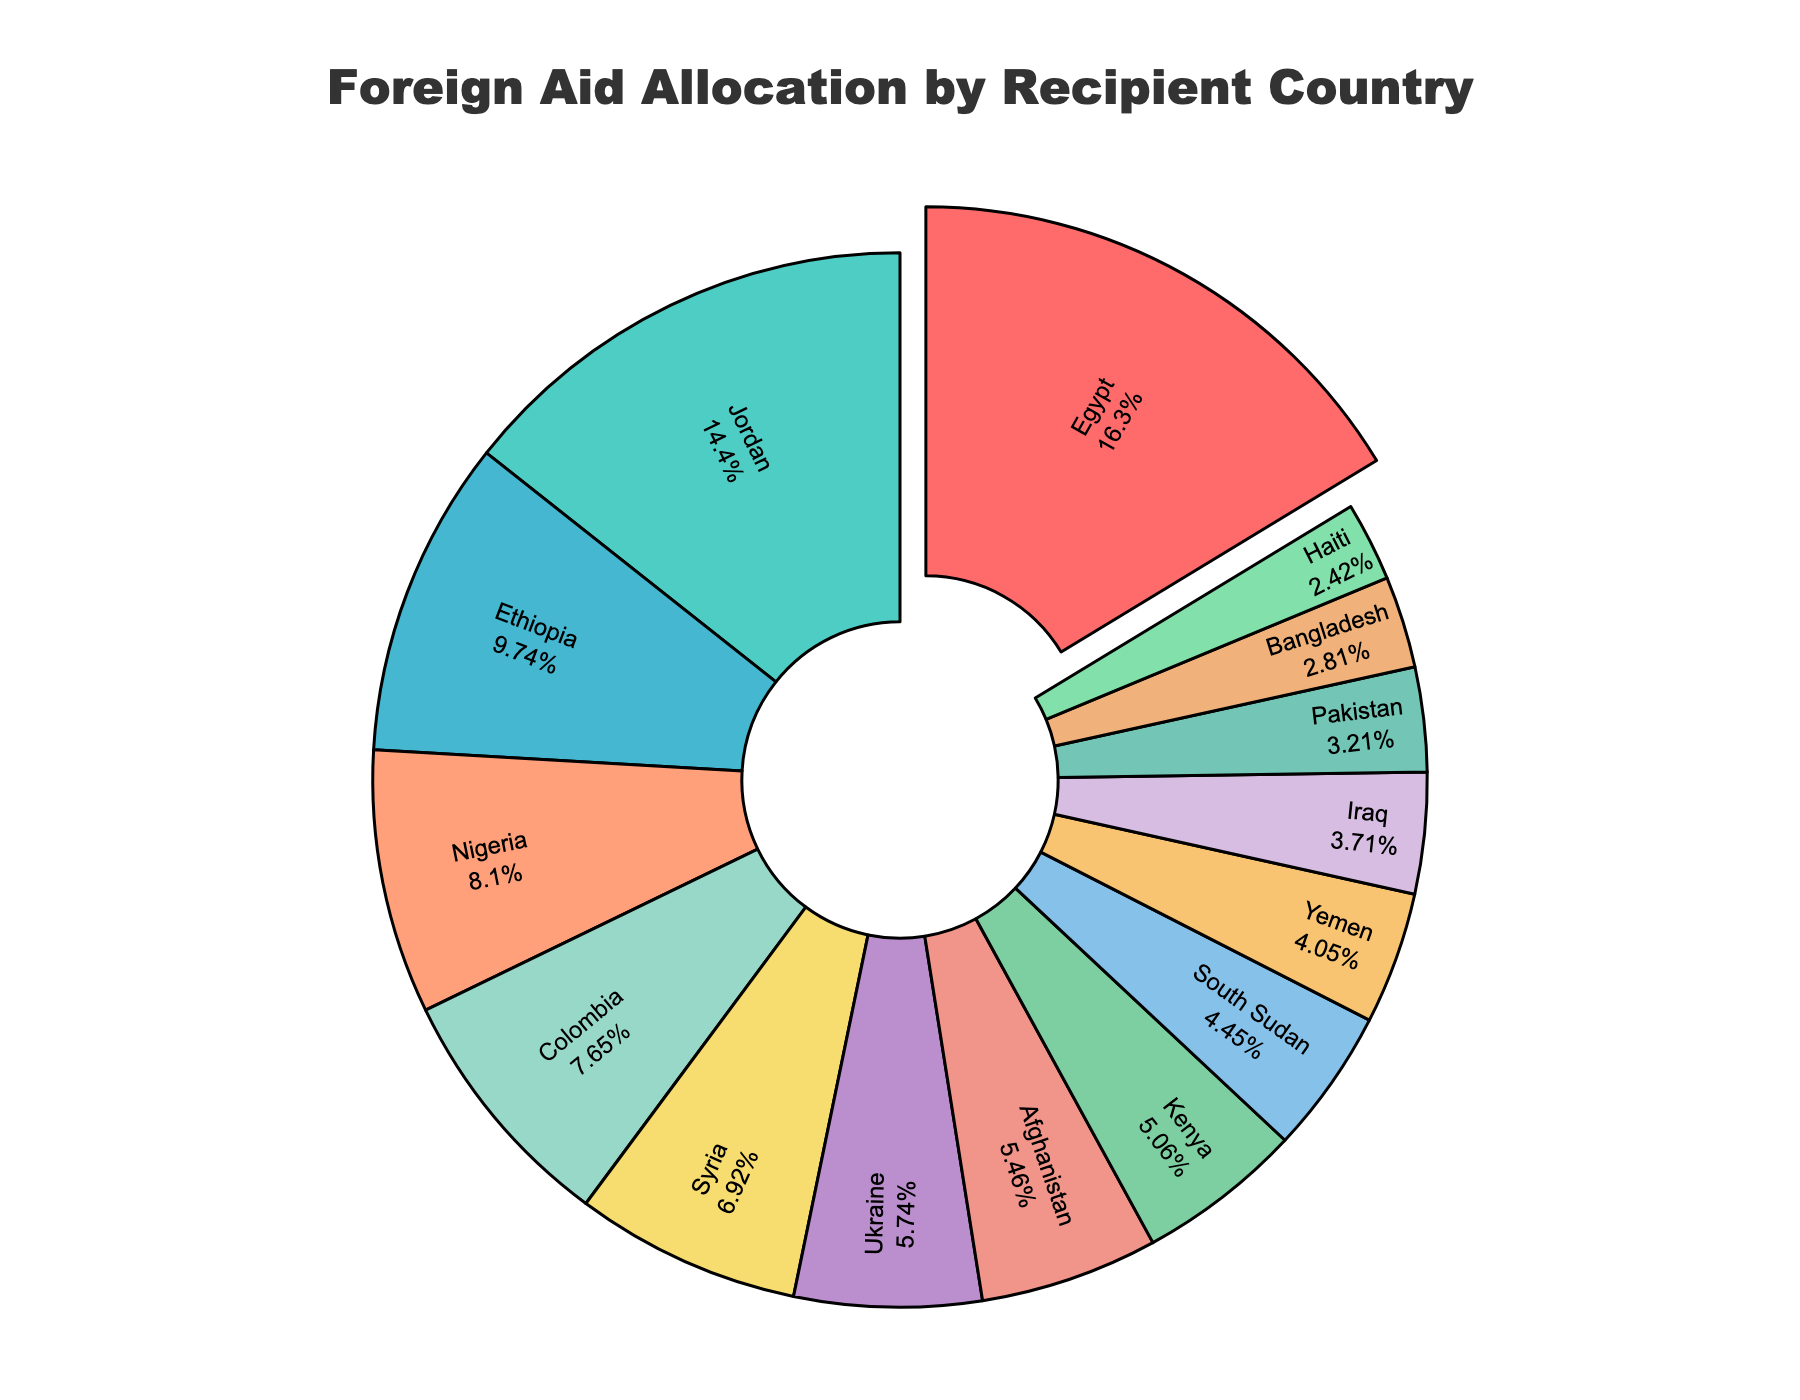What percentage of the total foreign aid does Egypt receive? Locate the segment labeled 'Egypt' on the pie chart. Note the percentage displayed next to Egypt.
Answer: 20.07% Which country receives more aid, Ethiopia or Nigeria? Compare the segments labeled 'Ethiopia' and 'Nigeria' in the pie chart. Ethiopia’s segment is larger than Nigeria’s.
Answer: Ethiopia What is the combined percentage of aid allocated to Jordan and Colombia? Find the segments for 'Jordan' and 'Colombia', then add their percentages together. Jordan's segment is 17.63% and Colombia’s is 9.40%. Therefore, the combined percentage is 17.63% + 9.40% = 27.03%.
Answer: 27.03% What fraction of the total aid is allocated to Afghanistan and Kenya combined? Identify the segments for 'Afghanistan' and 'Kenya' and sum their percentages. Afghanistan's segment is 6.71% and Kenya’s is 6.23%. Thus, the combined fraction = (6.71% + 6.23%) / 100 = 12.94%.
Answer: 12.94% Which country receives the least aid, and what is its percentage share? Locate the smallest segment in the pie chart which corresponds to Haiti. Haiti’s share is 2.97%.
Answer: Haiti, 2.97% By how much does the aid received by Yemen exceed that received by Iraq? Identify the segments for 'Yemen' and 'Iraq' and compare their sizes. Yemen’s segment is 4.98% whereas Iraq’s is 4.56%. Therefore, the difference is 4.98% - 4.56% = 0.42%.
Answer: 0.42% Is the aid allocation for Syria closer to Ukraine or South Sudan? Compare the percentage for Syria with those for Ukraine and South Sudan. Syria’s segment is 8.50%, Ukraine’s is 7.06%, and South Sudan’s is 5.47%. Therefore, Syria’s allocation is closer to Ukraine’s.
Answer: Ukraine How does the total aid allocation for countries in Africa (Ethiopia, Nigeria, Kenya, South Sudan) compare to that for countries in the Middle East (Egypt, Jordan, Syria, Yemen, Iraq)? Sum the percentages for African countries: Ethiopia (11.97%) + Nigeria (9.96%) + Kenya (6.23%) + South Sudan (5.47%) = 33.63%. Sum the percentages for Middle Eastern countries: Egypt (20.07%) + Jordan (17.63%) + Syria (8.50%) + Yemen (4.98%) + Iraq (4.56%) = 55.74%. Therefore, Middle Eastern countries receive 55.74% which is higher than 33.63% for African countries.
Answer: Middle East What visual feature is used to highlight the country receiving the most aid? The segment for Egypt has been "pulled out" or slightly separated from the rest of the pie, making it visually stand out.
Answer: Pulled out segment What is the average percentage share of aid for the top 5 countries? Identify the top 5 countries by their segment sizes, then calculate their average percentage. Egypt (20.07%), Jordan (17.63%), Ethiopia (11.97%), Nigeria (9.96%), and Colombia (9.40%). Average = (20.07% + 17.63% + 11.97% + 9.96% + 9.40%) / 5 = 13.81%.
Answer: 13.81% 